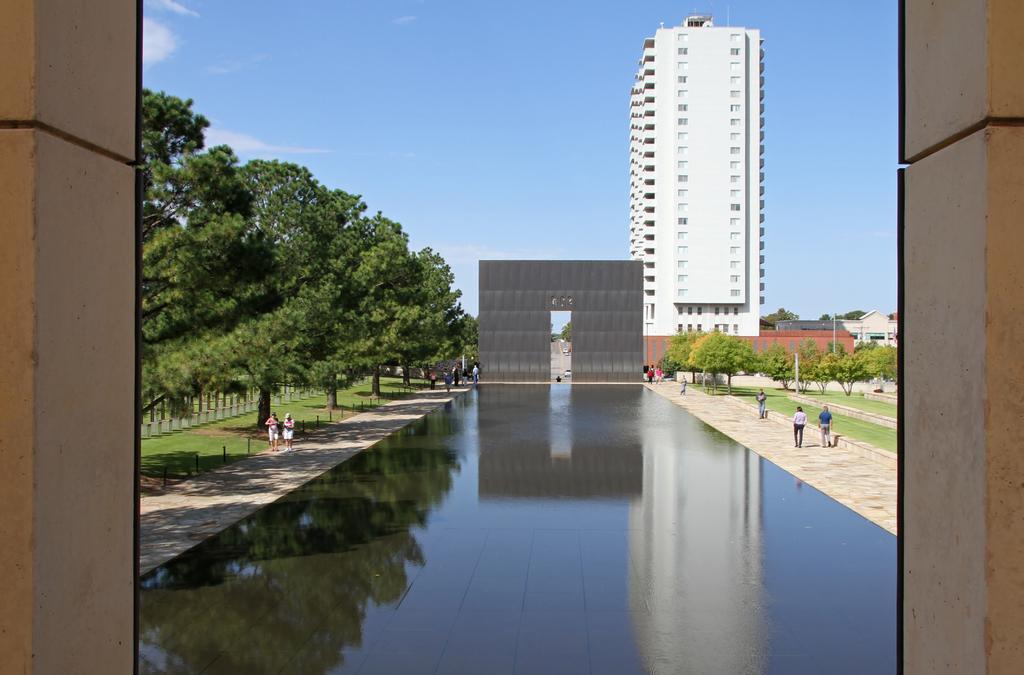How would you summarize this image in a sentence or two? In this picture I can see there is a building and there are few people walking at the right and left side, there are few trees at left side and there are few more trees in the right backdrop. The sky is clear. 